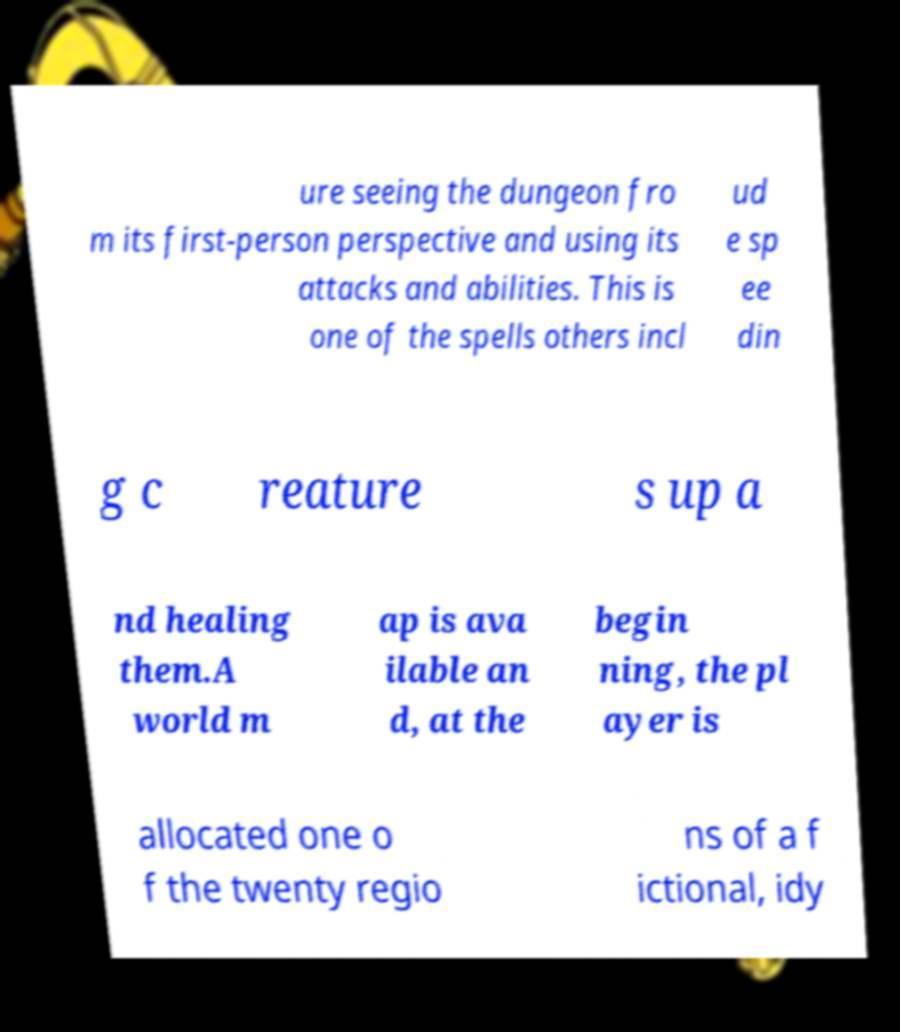Please identify and transcribe the text found in this image. ure seeing the dungeon fro m its first-person perspective and using its attacks and abilities. This is one of the spells others incl ud e sp ee din g c reature s up a nd healing them.A world m ap is ava ilable an d, at the begin ning, the pl ayer is allocated one o f the twenty regio ns of a f ictional, idy 